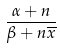<formula> <loc_0><loc_0><loc_500><loc_500>\frac { \alpha + n } { \beta + n \overline { x } }</formula> 